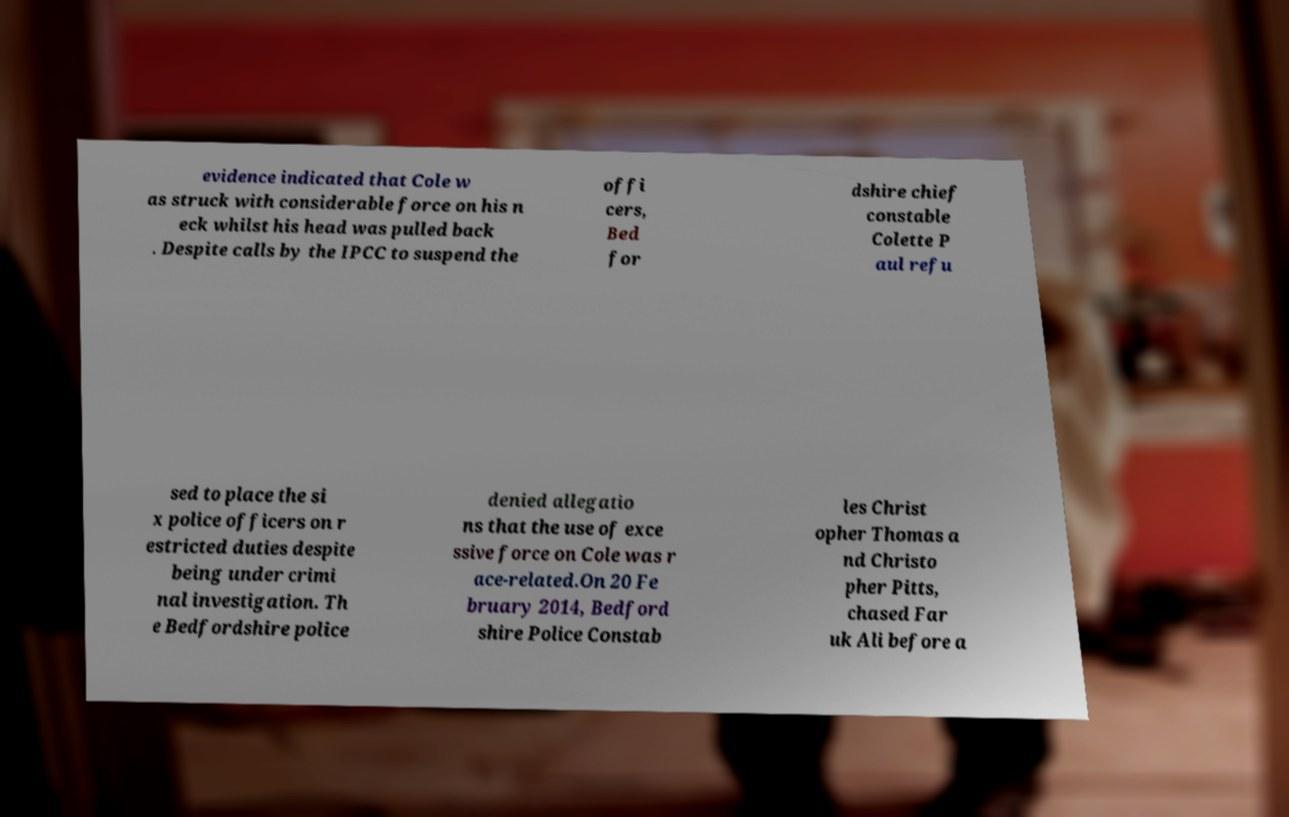What messages or text are displayed in this image? I need them in a readable, typed format. evidence indicated that Cole w as struck with considerable force on his n eck whilst his head was pulled back . Despite calls by the IPCC to suspend the offi cers, Bed for dshire chief constable Colette P aul refu sed to place the si x police officers on r estricted duties despite being under crimi nal investigation. Th e Bedfordshire police denied allegatio ns that the use of exce ssive force on Cole was r ace-related.On 20 Fe bruary 2014, Bedford shire Police Constab les Christ opher Thomas a nd Christo pher Pitts, chased Far uk Ali before a 